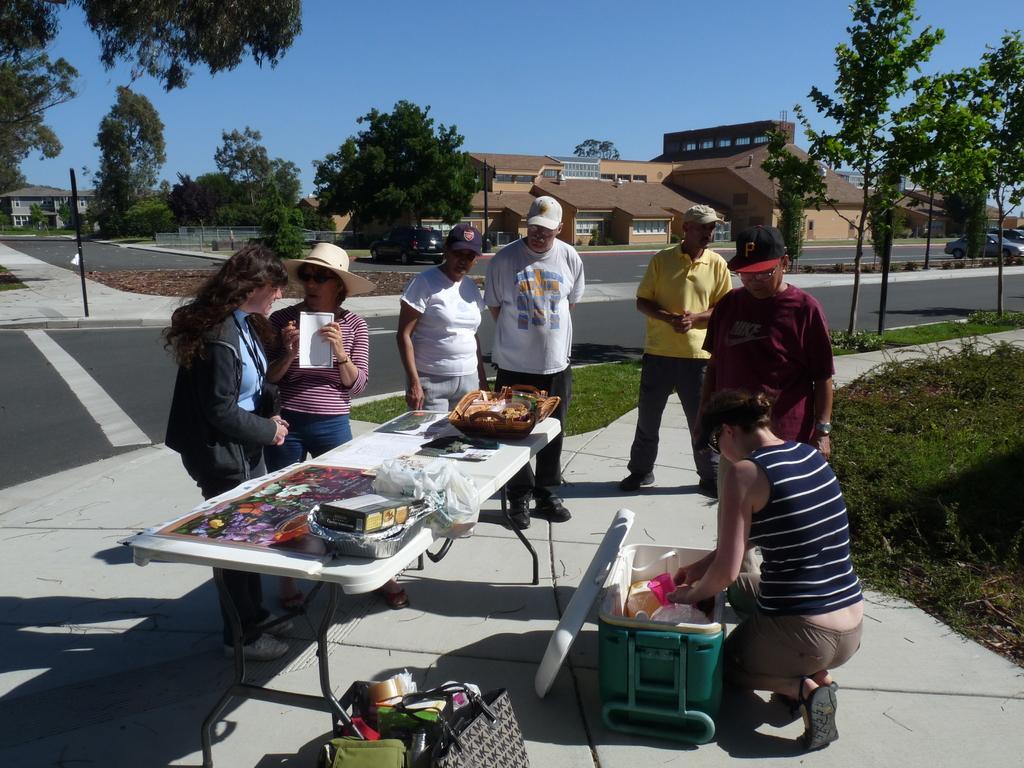Could you give a brief overview of what you see in this image? There are few people standing. Here is a woman sitting in squat position. This is the table with a basket,paper,tray and some objects on it. This is a basket with some things inside. I can see a handbag and some other bags placed here. This is the building with windows. These are the trees. I can see a car which is parked. This is the road. At background I can see another building. Here is another car moving on the road. 